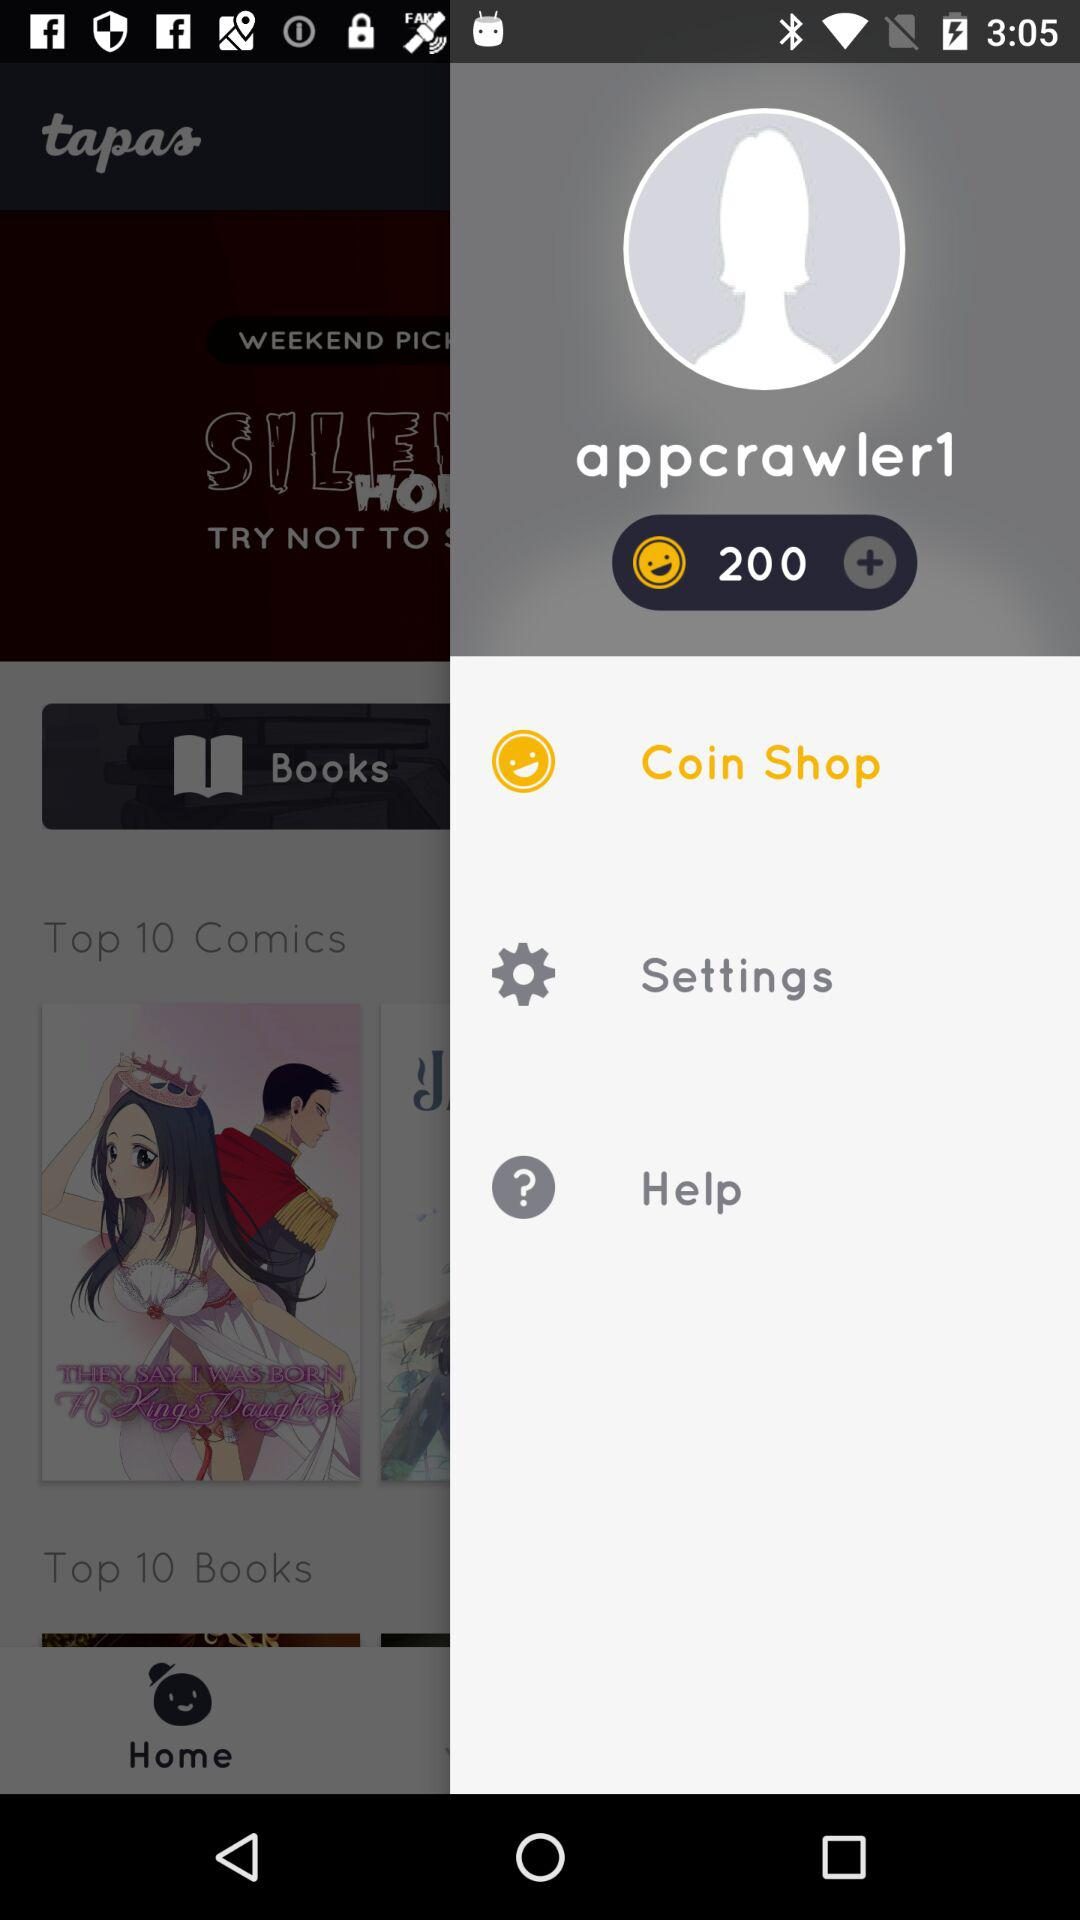What is the username? The username is "appcrawler1". 